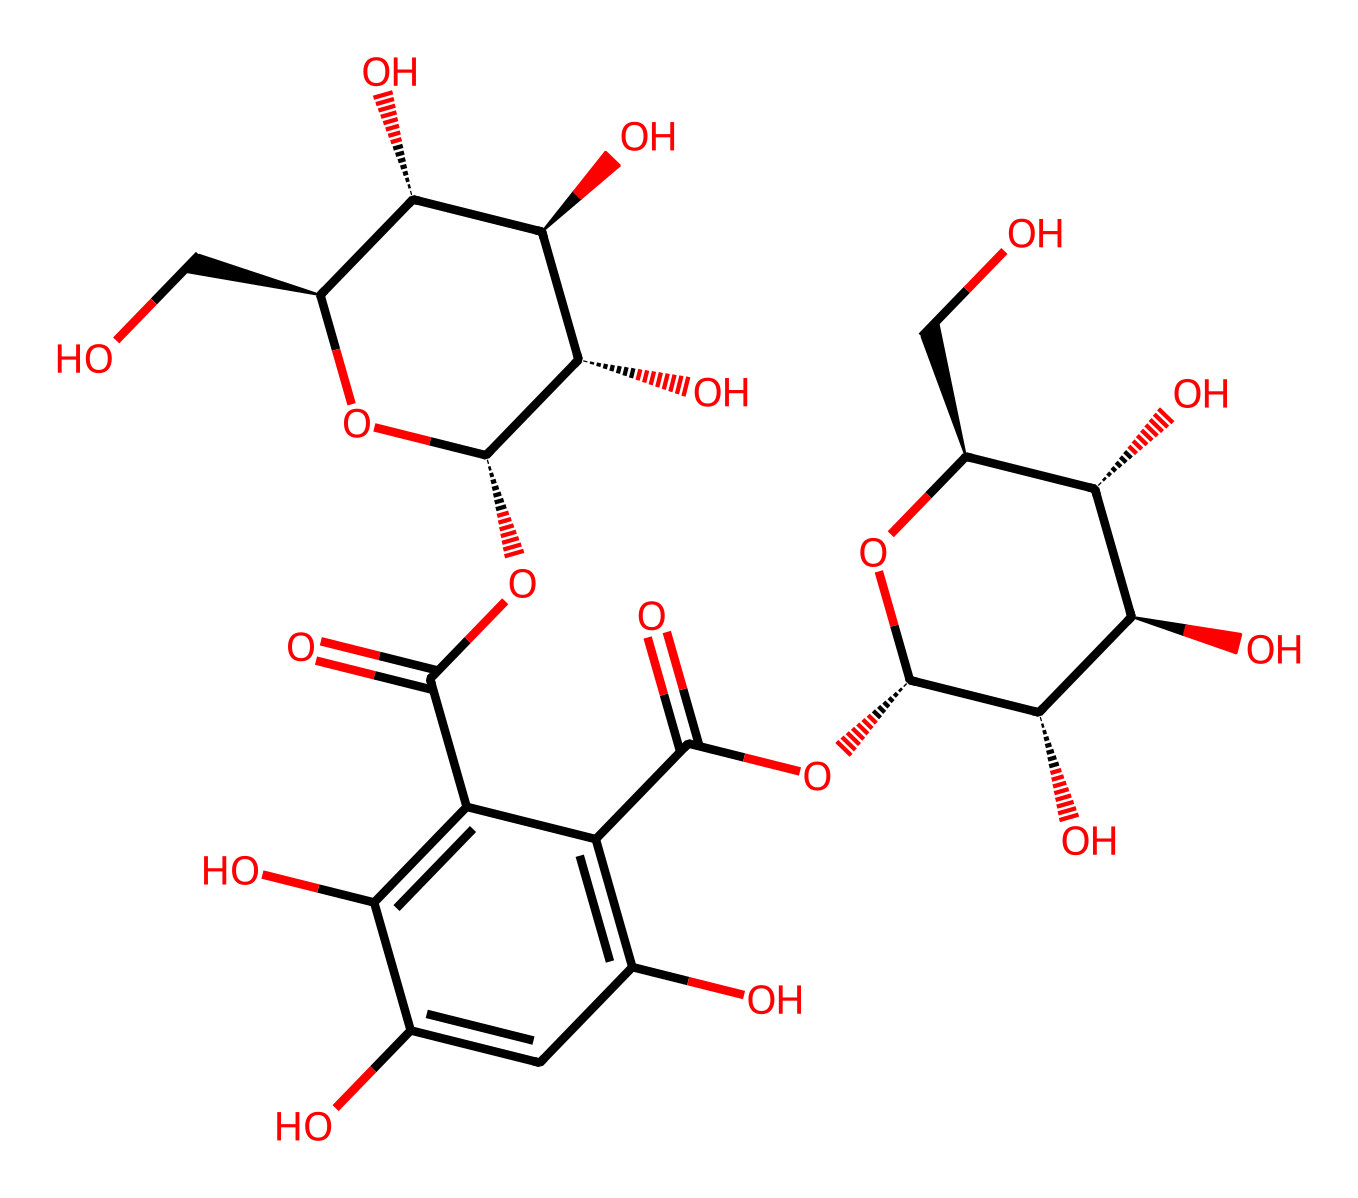What is the primary functional group present in this molecule? The molecule contains multiple hydroxyl groups (-OH), which are indicative of alcohols. This can be confirmed by counting the -OH groups in the structure and observing their placement throughout the molecule.
Answer: hydroxyl group How many carbon atoms are present in the molecule? By analyzing the SMILES representation, you can count the carbon atoms indicated by 'C'. Each 'C' represents a carbon atom. Upon counting, there are 15 carbon atoms in total.
Answer: 15 What type of chemical structure does this represent? The presence of multiple hydroxyl and carboxylic acid groups suggests that this molecule is a flavonoid, often found in natural astringents such as witch hazel. The structure's complexity and presence of rings further support this classification.
Answer: flavonoid How many rings are present in this chemical structure? The structure reveals two ring systems due to the circular arrangement of carbon atoms and the presence of double bonds that indicate ring formation. Upon examination, there are two distinct rings observable in the structure.
Answer: 2 Which elements are predominantly featured in the molecule? Analyzing the SMILES representation, it includes carbon (C), hydrogen (H), and oxygen (O). The presence of these elements can be identified by their symbols in the string, with oxygen being crucial for the functional groups identified earlier.
Answer: carbon, hydrogen, oxygen What does the presence of carboxylic acid groups indicate about this molecule? The carboxylic acid groups (–COOH) contribute to the molecule's acidity and astringent properties, which are beneficial for soothing skin irritations. These functional groups enhance the molecule's reactivity and its utility as a natural remedy.
Answer: acidity, astringent properties 